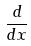<formula> <loc_0><loc_0><loc_500><loc_500>\frac { d } { d x }</formula> 